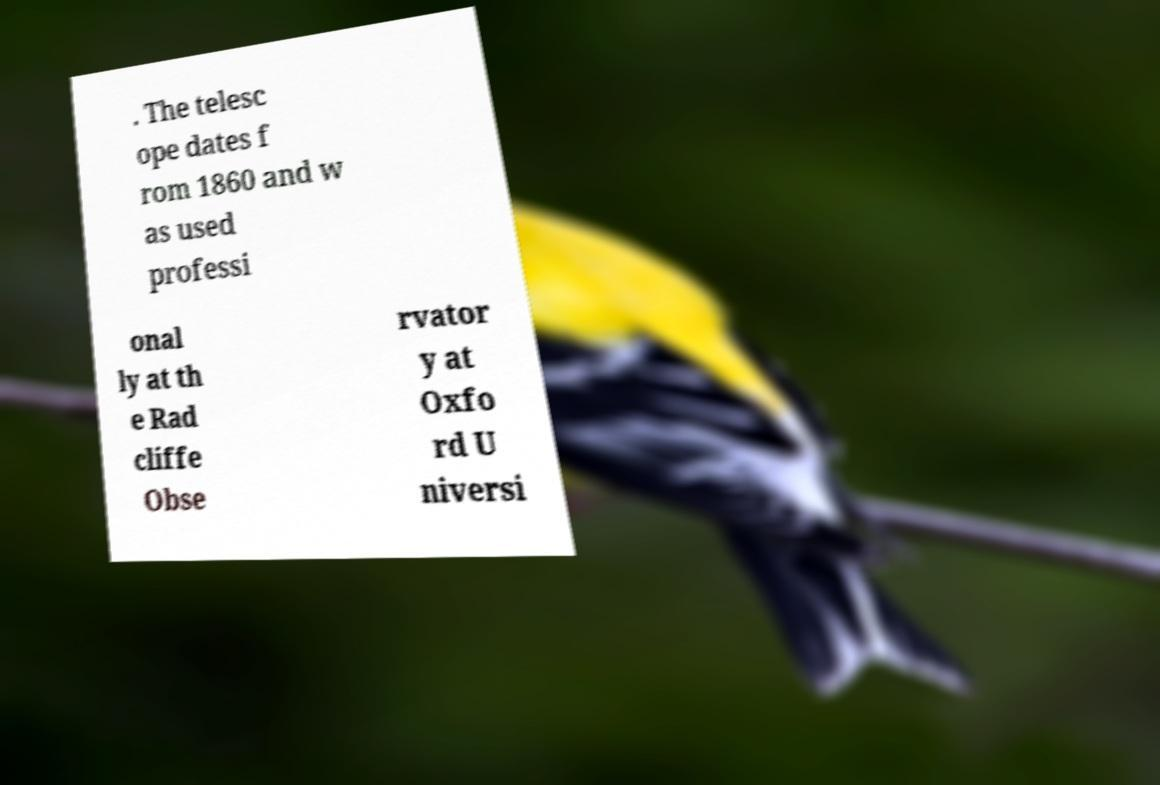There's text embedded in this image that I need extracted. Can you transcribe it verbatim? . The telesc ope dates f rom 1860 and w as used professi onal ly at th e Rad cliffe Obse rvator y at Oxfo rd U niversi 